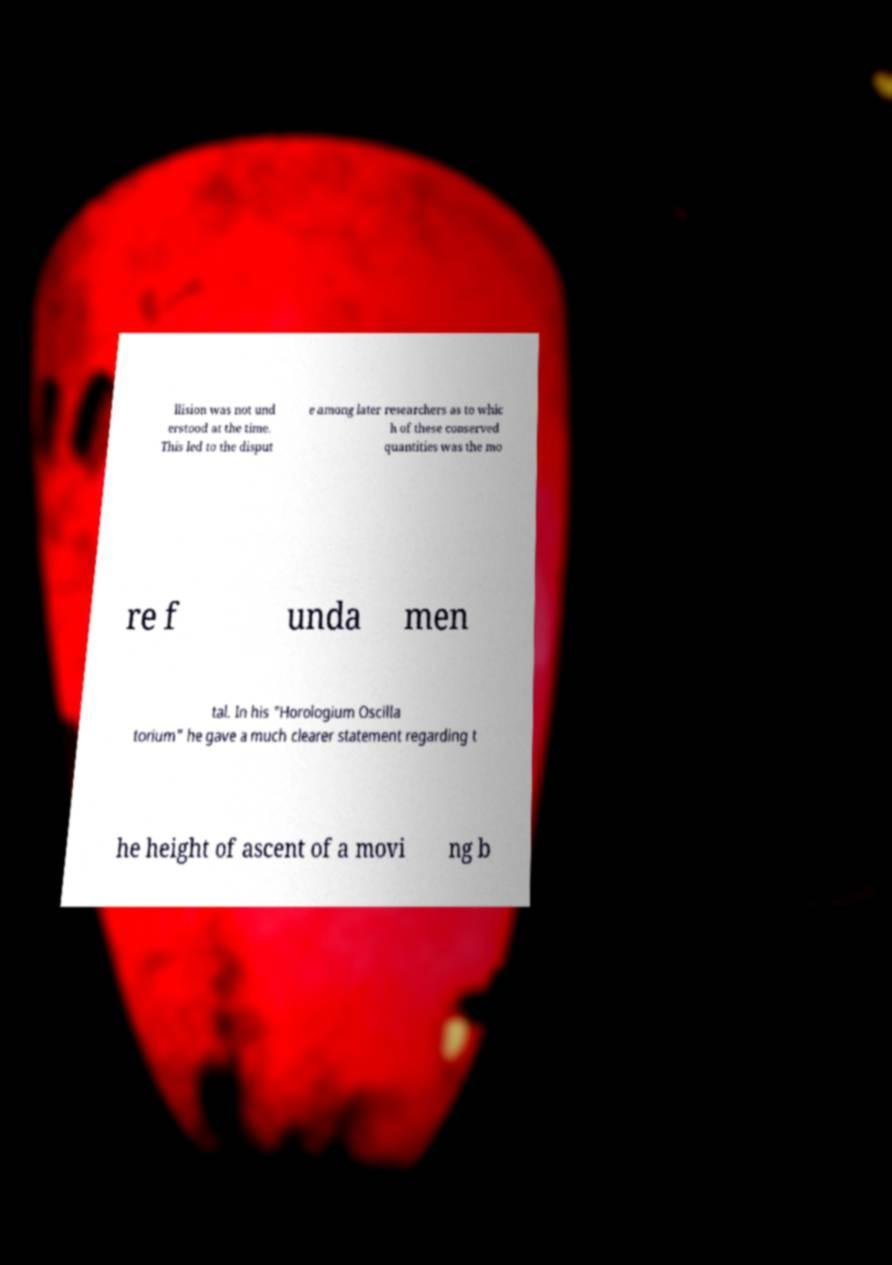Please read and relay the text visible in this image. What does it say? llision was not und erstood at the time. This led to the disput e among later researchers as to whic h of these conserved quantities was the mo re f unda men tal. In his "Horologium Oscilla torium" he gave a much clearer statement regarding t he height of ascent of a movi ng b 